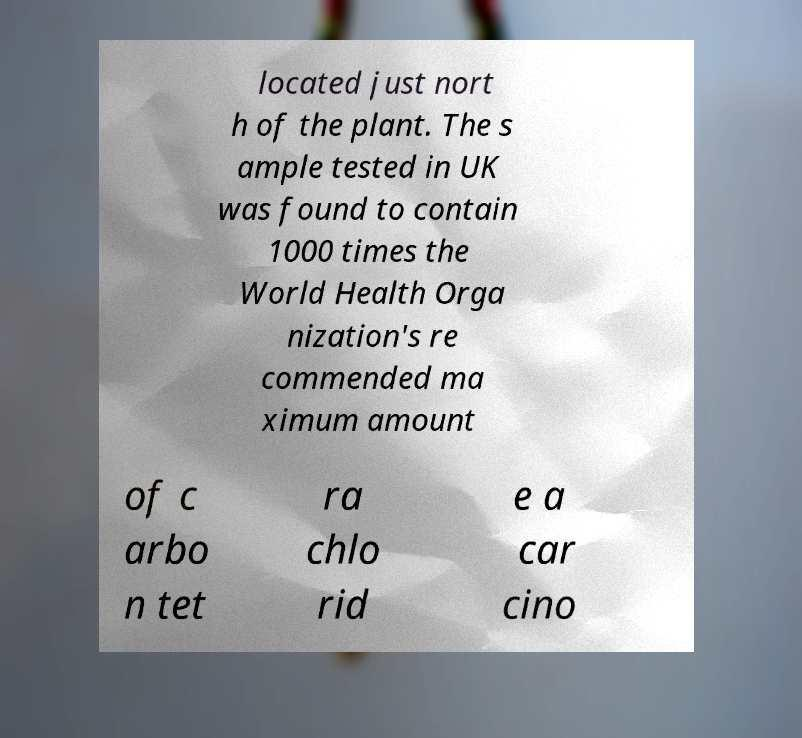What messages or text are displayed in this image? I need them in a readable, typed format. located just nort h of the plant. The s ample tested in UK was found to contain 1000 times the World Health Orga nization's re commended ma ximum amount of c arbo n tet ra chlo rid e a car cino 